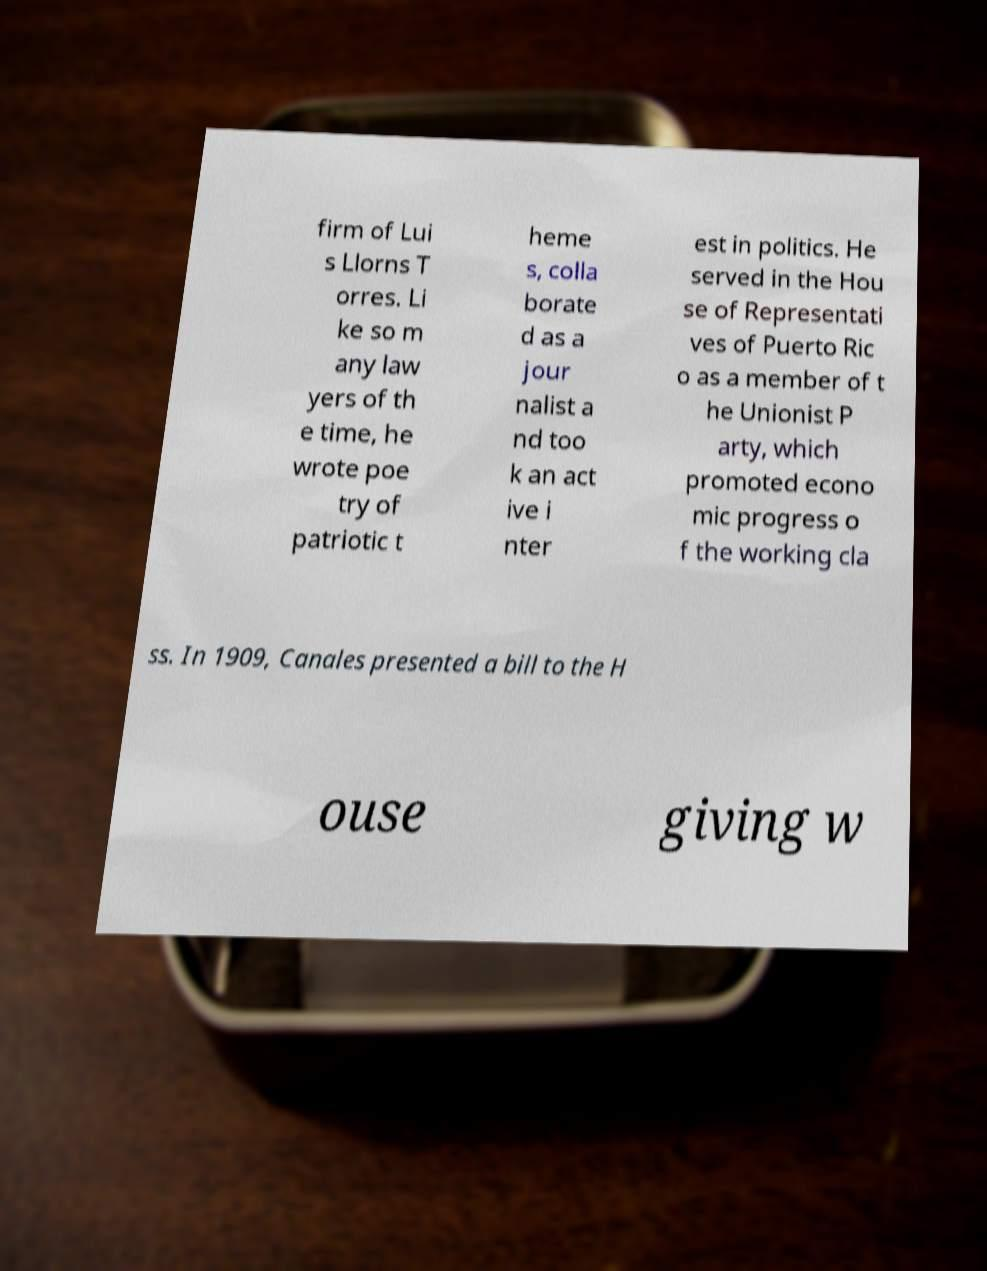Can you read and provide the text displayed in the image?This photo seems to have some interesting text. Can you extract and type it out for me? firm of Lui s Llorns T orres. Li ke so m any law yers of th e time, he wrote poe try of patriotic t heme s, colla borate d as a jour nalist a nd too k an act ive i nter est in politics. He served in the Hou se of Representati ves of Puerto Ric o as a member of t he Unionist P arty, which promoted econo mic progress o f the working cla ss. In 1909, Canales presented a bill to the H ouse giving w 